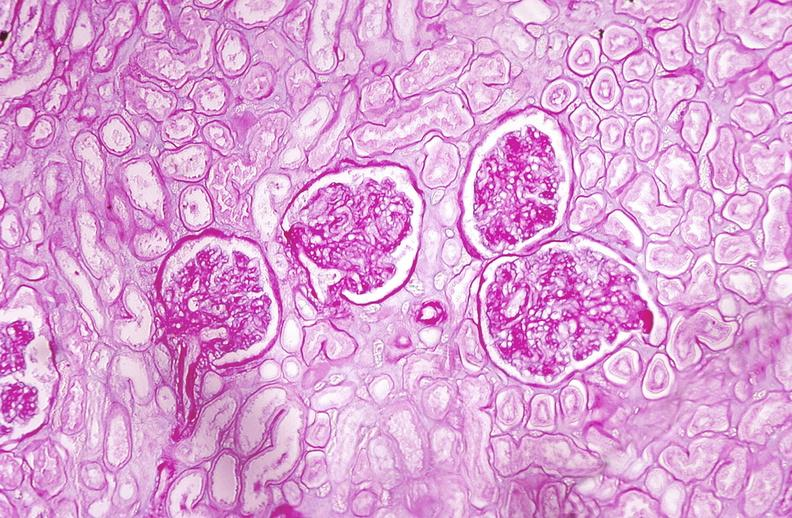what does this image show?
Answer the question using a single word or phrase. Kidney glomerulus 